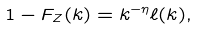Convert formula to latex. <formula><loc_0><loc_0><loc_500><loc_500>1 - F _ { Z } ( k ) = k ^ { - \eta } \ell ( k ) ,</formula> 